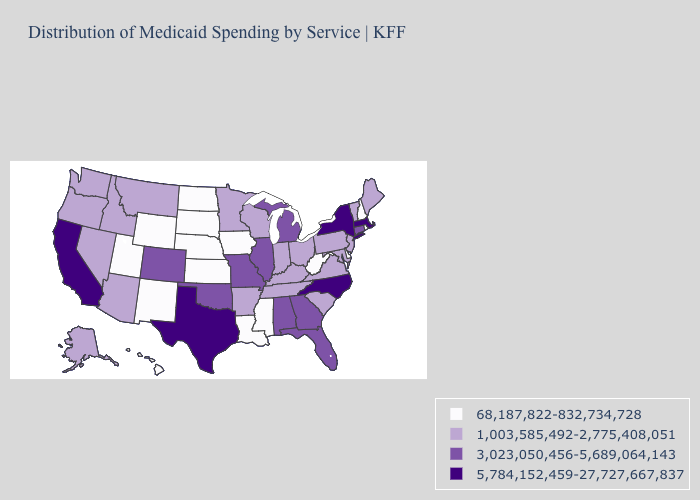What is the value of Iowa?
Concise answer only. 68,187,822-832,734,728. What is the highest value in the USA?
Answer briefly. 5,784,152,459-27,727,667,837. How many symbols are there in the legend?
Write a very short answer. 4. Does Mississippi have the lowest value in the South?
Write a very short answer. Yes. Among the states that border Florida , which have the highest value?
Be succinct. Alabama, Georgia. Does Rhode Island have a higher value than Colorado?
Keep it brief. No. What is the lowest value in the USA?
Keep it brief. 68,187,822-832,734,728. What is the highest value in the USA?
Be succinct. 5,784,152,459-27,727,667,837. Does the first symbol in the legend represent the smallest category?
Answer briefly. Yes. Does the first symbol in the legend represent the smallest category?
Keep it brief. Yes. What is the value of Tennessee?
Short answer required. 1,003,585,492-2,775,408,051. Name the states that have a value in the range 3,023,050,456-5,689,064,143?
Keep it brief. Alabama, Colorado, Connecticut, Florida, Georgia, Illinois, Michigan, Missouri, Oklahoma. Name the states that have a value in the range 1,003,585,492-2,775,408,051?
Short answer required. Alaska, Arizona, Arkansas, Idaho, Indiana, Kentucky, Maine, Maryland, Minnesota, Montana, Nevada, New Jersey, Ohio, Oregon, Pennsylvania, South Carolina, Tennessee, Vermont, Virginia, Washington, Wisconsin. Name the states that have a value in the range 5,784,152,459-27,727,667,837?
Quick response, please. California, Massachusetts, New York, North Carolina, Texas. What is the value of Maine?
Answer briefly. 1,003,585,492-2,775,408,051. 